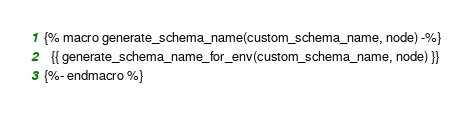Convert code to text. <code><loc_0><loc_0><loc_500><loc_500><_SQL_>{% macro generate_schema_name(custom_schema_name, node) -%}
  {{ generate_schema_name_for_env(custom_schema_name, node) }}
{%- endmacro %}
</code> 